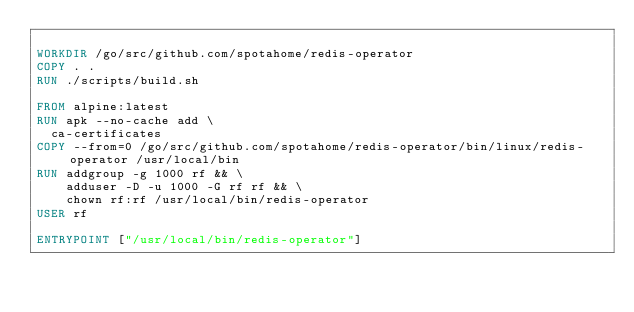<code> <loc_0><loc_0><loc_500><loc_500><_Dockerfile_>
WORKDIR /go/src/github.com/spotahome/redis-operator
COPY . .
RUN ./scripts/build.sh

FROM alpine:latest
RUN apk --no-cache add \
  ca-certificates
COPY --from=0 /go/src/github.com/spotahome/redis-operator/bin/linux/redis-operator /usr/local/bin
RUN addgroup -g 1000 rf && \
    adduser -D -u 1000 -G rf rf && \
    chown rf:rf /usr/local/bin/redis-operator
USER rf

ENTRYPOINT ["/usr/local/bin/redis-operator"]
</code> 